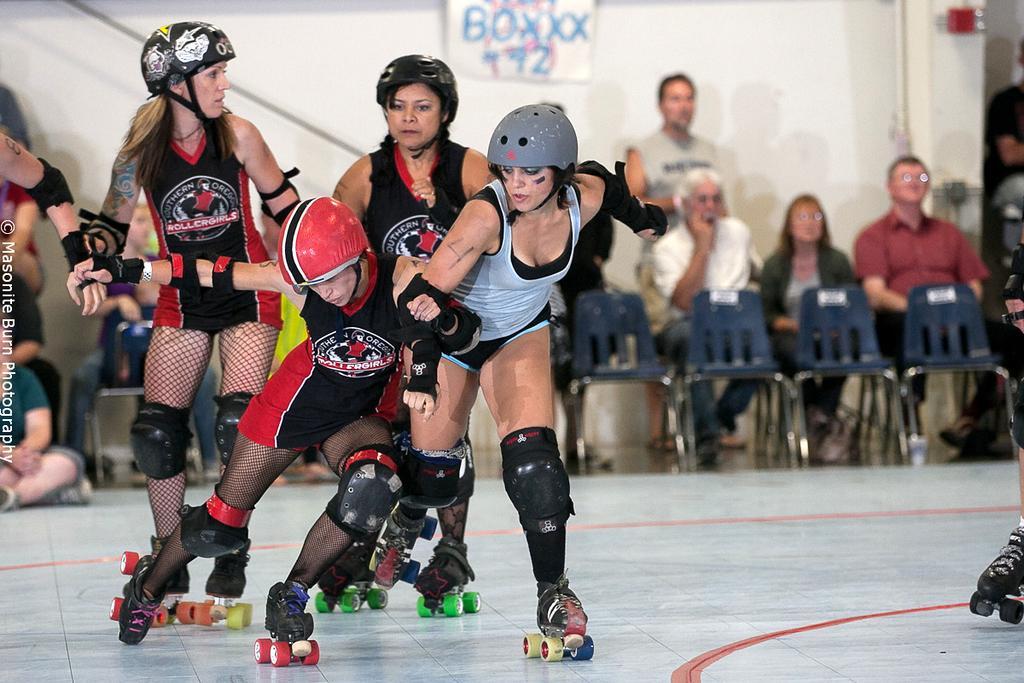Please provide a concise description of this image. In this picture we can see some people skating on the ground, they are wearing helmets and in the background we can see a group of people, chairs, wall, poster and some objects. 